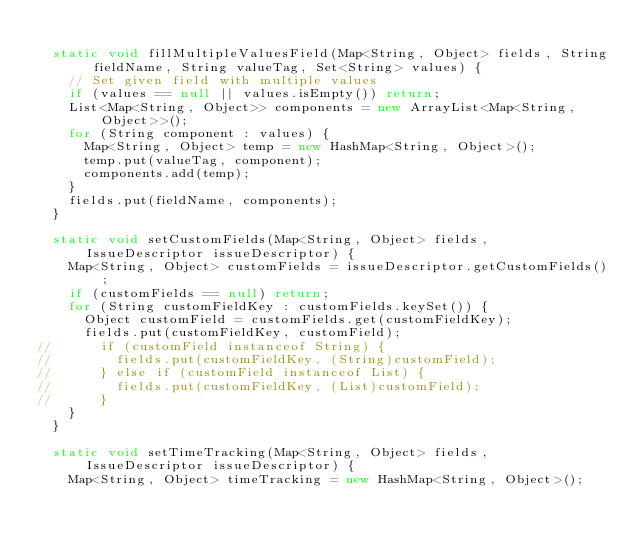Convert code to text. <code><loc_0><loc_0><loc_500><loc_500><_Java_>
	static void fillMultipleValuesField(Map<String, Object> fields, String fieldName, String valueTag, Set<String> values) {
		// Set given field with multiple values
		if (values == null || values.isEmpty()) return;
		List<Map<String, Object>> components = new ArrayList<Map<String, Object>>();
		for (String component : values) {
			Map<String, Object> temp = new HashMap<String, Object>();
			temp.put(valueTag, component);
			components.add(temp);
		}
		fields.put(fieldName, components);
	}
	
	static void setCustomFields(Map<String, Object> fields, IssueDescriptor issueDescriptor) {
		Map<String, Object> customFields = issueDescriptor.getCustomFields();
		if (customFields == null) return;
		for (String customFieldKey : customFields.keySet()) {
			Object customField = customFields.get(customFieldKey);
			fields.put(customFieldKey, customField);
//			if (customField instanceof String) {
//				fields.put(customFieldKey, (String)customField);
//			} else if (customField instanceof List) {
//				fields.put(customFieldKey, (List)customField);
//			}
		}
	}
	
	static void setTimeTracking(Map<String, Object> fields, IssueDescriptor issueDescriptor) {
		Map<String, Object> timeTracking = new HashMap<String, Object>();</code> 